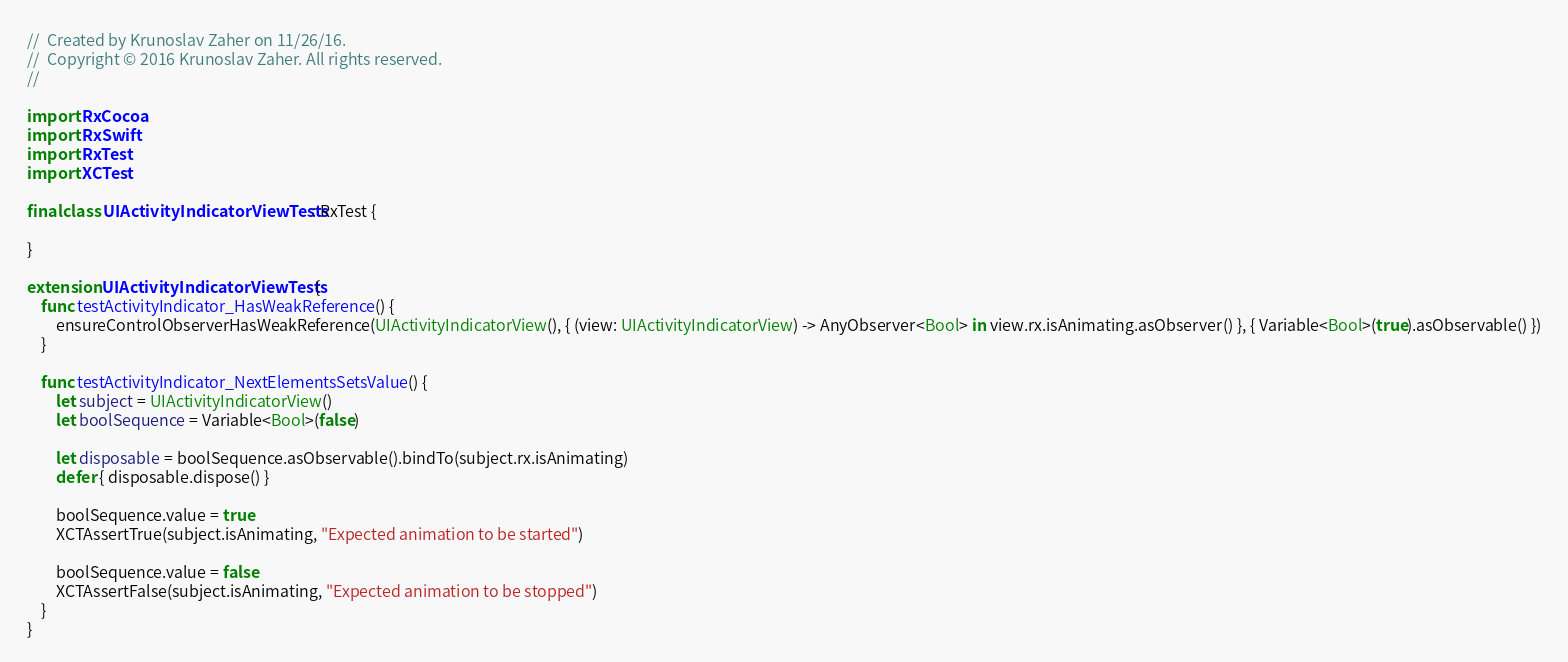<code> <loc_0><loc_0><loc_500><loc_500><_Swift_>//  Created by Krunoslav Zaher on 11/26/16.
//  Copyright © 2016 Krunoslav Zaher. All rights reserved.
//

import RxCocoa
import RxSwift
import RxTest
import XCTest

final class UIActivityIndicatorViewTests: RxTest {

}

extension UIActivityIndicatorViewTests {
    func testActivityIndicator_HasWeakReference() {
        ensureControlObserverHasWeakReference(UIActivityIndicatorView(), { (view: UIActivityIndicatorView) -> AnyObserver<Bool> in view.rx.isAnimating.asObserver() }, { Variable<Bool>(true).asObservable() })
    }

    func testActivityIndicator_NextElementsSetsValue() {
        let subject = UIActivityIndicatorView()
        let boolSequence = Variable<Bool>(false)

        let disposable = boolSequence.asObservable().bindTo(subject.rx.isAnimating)
        defer { disposable.dispose() }

        boolSequence.value = true
        XCTAssertTrue(subject.isAnimating, "Expected animation to be started")

        boolSequence.value = false
        XCTAssertFalse(subject.isAnimating, "Expected animation to be stopped")
    }
}
</code> 